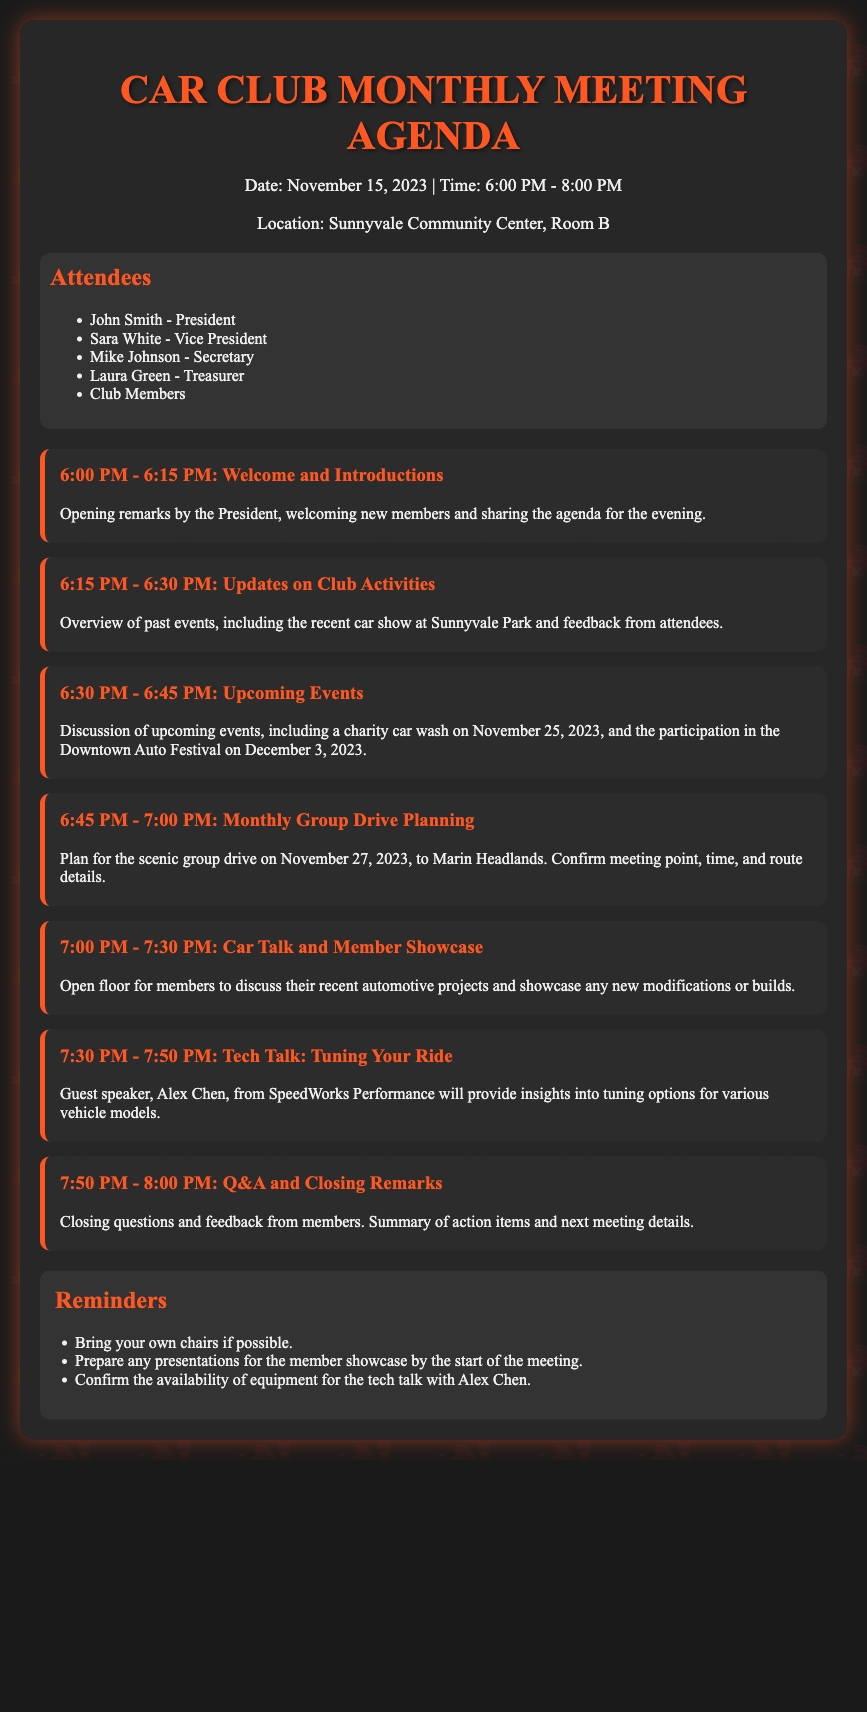What is the date of the meeting? The date of the meeting is stated clearly at the top of the document as November 15, 2023.
Answer: November 15, 2023 Who is the guest speaker? The guest speaker is mentioned in the agenda item for the tech talk section, stating that it is Alex Chen.
Answer: Alex Chen What time does the group drive start? The group drive planning section indicates that it is set for November 27, 2023, without a specific start time detailed.
Answer: November 27, 2023 What is the location of the meeting? The location is provided in the header information of the document as Sunnyvale Community Center, Room B.
Answer: Sunnyvale Community Center, Room B How long is the car talk session? The duration for the car talk and member showcase is mentioned in the agenda, which shows it is for 30 minutes.
Answer: 30 minutes What is the purpose of the monthly group drive? The purpose is described in the agenda item, focusing on planning a drive to a scenic location, specifically the Marin Headlands.
Answer: Scenic drive How many attendees are listed? The attendee section lists four main officers and states there are additional club members present.
Answer: Four main officers When is the charity car wash scheduled? The upcoming events section lists the charity car wash date as November 25, 2023.
Answer: November 25, 2023 What should members bring to the meeting? The reminders section highlights that members are advised to bring their own chairs if possible.
Answer: Own chairs 